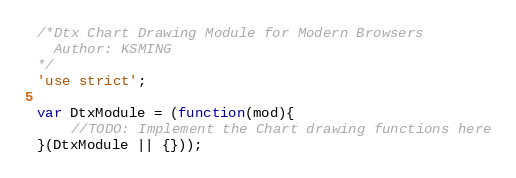Convert code to text. <code><loc_0><loc_0><loc_500><loc_500><_JavaScript_>/*Dtx Chart Drawing Module for Modern Browsers
  Author: KSMING
*/
'use strict';

var DtxModule = (function(mod){
    //TODO: Implement the Chart drawing functions here
}(DtxModule || {}));</code> 